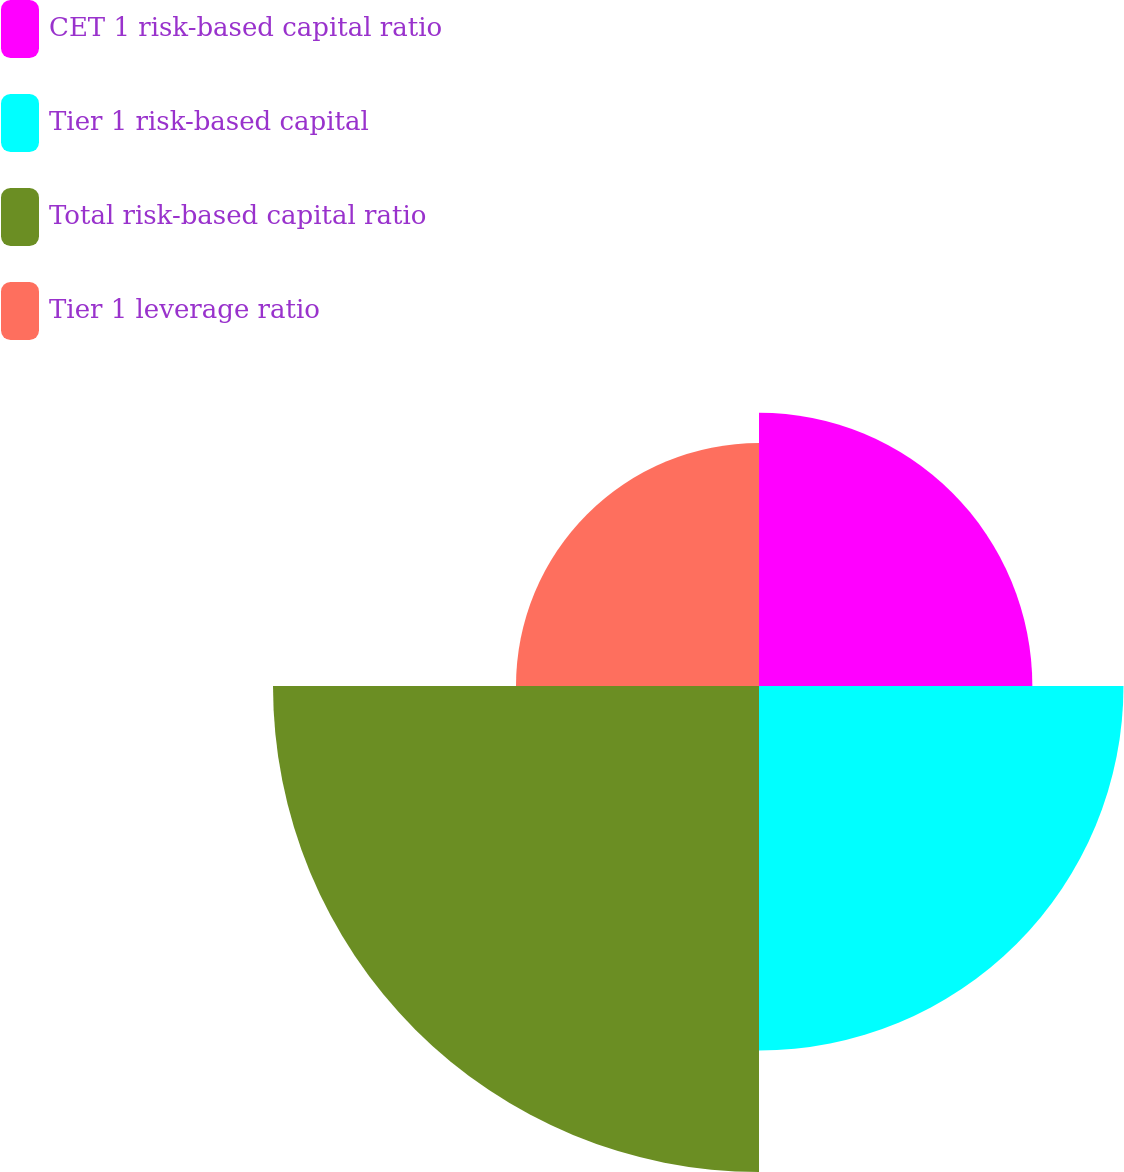Convert chart. <chart><loc_0><loc_0><loc_500><loc_500><pie_chart><fcel>CET 1 risk-based capital ratio<fcel>Tier 1 risk-based capital<fcel>Total risk-based capital ratio<fcel>Tier 1 leverage ratio<nl><fcel>20.0%<fcel>26.67%<fcel>35.56%<fcel>17.78%<nl></chart> 